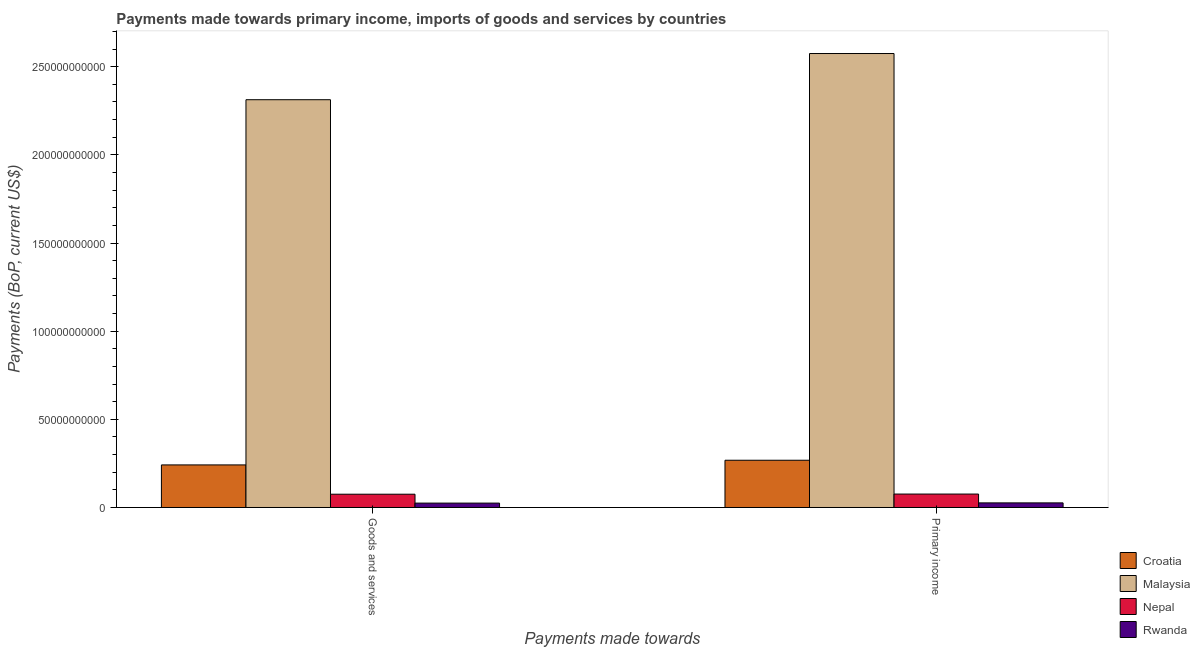How many different coloured bars are there?
Your answer should be very brief. 4. Are the number of bars per tick equal to the number of legend labels?
Your answer should be compact. Yes. How many bars are there on the 1st tick from the left?
Your answer should be compact. 4. How many bars are there on the 2nd tick from the right?
Your response must be concise. 4. What is the label of the 1st group of bars from the left?
Provide a succinct answer. Goods and services. What is the payments made towards primary income in Malaysia?
Ensure brevity in your answer.  2.57e+11. Across all countries, what is the maximum payments made towards goods and services?
Your answer should be compact. 2.31e+11. Across all countries, what is the minimum payments made towards primary income?
Your response must be concise. 2.61e+09. In which country was the payments made towards goods and services maximum?
Provide a short and direct response. Malaysia. In which country was the payments made towards primary income minimum?
Ensure brevity in your answer.  Rwanda. What is the total payments made towards primary income in the graph?
Give a very brief answer. 2.95e+11. What is the difference between the payments made towards goods and services in Rwanda and that in Malaysia?
Provide a short and direct response. -2.29e+11. What is the difference between the payments made towards goods and services in Croatia and the payments made towards primary income in Malaysia?
Ensure brevity in your answer.  -2.33e+11. What is the average payments made towards primary income per country?
Your response must be concise. 7.36e+1. What is the difference between the payments made towards primary income and payments made towards goods and services in Malaysia?
Provide a short and direct response. 2.62e+1. What is the ratio of the payments made towards goods and services in Croatia to that in Rwanda?
Keep it short and to the point. 9.72. Is the payments made towards goods and services in Nepal less than that in Malaysia?
Keep it short and to the point. Yes. What does the 2nd bar from the left in Primary income represents?
Give a very brief answer. Malaysia. What does the 2nd bar from the right in Primary income represents?
Provide a short and direct response. Nepal. How many bars are there?
Ensure brevity in your answer.  8. Are all the bars in the graph horizontal?
Give a very brief answer. No. Are the values on the major ticks of Y-axis written in scientific E-notation?
Ensure brevity in your answer.  No. How many legend labels are there?
Offer a terse response. 4. How are the legend labels stacked?
Offer a terse response. Vertical. What is the title of the graph?
Your answer should be very brief. Payments made towards primary income, imports of goods and services by countries. What is the label or title of the X-axis?
Offer a terse response. Payments made towards. What is the label or title of the Y-axis?
Provide a short and direct response. Payments (BoP, current US$). What is the Payments (BoP, current US$) in Croatia in Goods and services?
Keep it short and to the point. 2.42e+1. What is the Payments (BoP, current US$) of Malaysia in Goods and services?
Your response must be concise. 2.31e+11. What is the Payments (BoP, current US$) in Nepal in Goods and services?
Provide a succinct answer. 7.53e+09. What is the Payments (BoP, current US$) in Rwanda in Goods and services?
Give a very brief answer. 2.48e+09. What is the Payments (BoP, current US$) of Croatia in Primary income?
Your response must be concise. 2.68e+1. What is the Payments (BoP, current US$) in Malaysia in Primary income?
Give a very brief answer. 2.57e+11. What is the Payments (BoP, current US$) of Nepal in Primary income?
Your answer should be compact. 7.62e+09. What is the Payments (BoP, current US$) of Rwanda in Primary income?
Give a very brief answer. 2.61e+09. Across all Payments made towards, what is the maximum Payments (BoP, current US$) in Croatia?
Keep it short and to the point. 2.68e+1. Across all Payments made towards, what is the maximum Payments (BoP, current US$) in Malaysia?
Make the answer very short. 2.57e+11. Across all Payments made towards, what is the maximum Payments (BoP, current US$) of Nepal?
Provide a short and direct response. 7.62e+09. Across all Payments made towards, what is the maximum Payments (BoP, current US$) in Rwanda?
Make the answer very short. 2.61e+09. Across all Payments made towards, what is the minimum Payments (BoP, current US$) in Croatia?
Offer a terse response. 2.42e+1. Across all Payments made towards, what is the minimum Payments (BoP, current US$) of Malaysia?
Keep it short and to the point. 2.31e+11. Across all Payments made towards, what is the minimum Payments (BoP, current US$) of Nepal?
Give a very brief answer. 7.53e+09. Across all Payments made towards, what is the minimum Payments (BoP, current US$) in Rwanda?
Make the answer very short. 2.48e+09. What is the total Payments (BoP, current US$) in Croatia in the graph?
Your answer should be very brief. 5.09e+1. What is the total Payments (BoP, current US$) of Malaysia in the graph?
Offer a very short reply. 4.89e+11. What is the total Payments (BoP, current US$) of Nepal in the graph?
Your answer should be very brief. 1.51e+1. What is the total Payments (BoP, current US$) of Rwanda in the graph?
Provide a succinct answer. 5.10e+09. What is the difference between the Payments (BoP, current US$) in Croatia in Goods and services and that in Primary income?
Your answer should be very brief. -2.64e+09. What is the difference between the Payments (BoP, current US$) of Malaysia in Goods and services and that in Primary income?
Your answer should be very brief. -2.62e+1. What is the difference between the Payments (BoP, current US$) in Nepal in Goods and services and that in Primary income?
Your answer should be very brief. -9.06e+07. What is the difference between the Payments (BoP, current US$) in Rwanda in Goods and services and that in Primary income?
Ensure brevity in your answer.  -1.30e+08. What is the difference between the Payments (BoP, current US$) of Croatia in Goods and services and the Payments (BoP, current US$) of Malaysia in Primary income?
Your answer should be very brief. -2.33e+11. What is the difference between the Payments (BoP, current US$) of Croatia in Goods and services and the Payments (BoP, current US$) of Nepal in Primary income?
Your response must be concise. 1.65e+1. What is the difference between the Payments (BoP, current US$) in Croatia in Goods and services and the Payments (BoP, current US$) in Rwanda in Primary income?
Keep it short and to the point. 2.15e+1. What is the difference between the Payments (BoP, current US$) in Malaysia in Goods and services and the Payments (BoP, current US$) in Nepal in Primary income?
Provide a succinct answer. 2.24e+11. What is the difference between the Payments (BoP, current US$) in Malaysia in Goods and services and the Payments (BoP, current US$) in Rwanda in Primary income?
Keep it short and to the point. 2.29e+11. What is the difference between the Payments (BoP, current US$) in Nepal in Goods and services and the Payments (BoP, current US$) in Rwanda in Primary income?
Your response must be concise. 4.91e+09. What is the average Payments (BoP, current US$) in Croatia per Payments made towards?
Your response must be concise. 2.55e+1. What is the average Payments (BoP, current US$) of Malaysia per Payments made towards?
Give a very brief answer. 2.44e+11. What is the average Payments (BoP, current US$) of Nepal per Payments made towards?
Give a very brief answer. 7.57e+09. What is the average Payments (BoP, current US$) in Rwanda per Payments made towards?
Provide a short and direct response. 2.55e+09. What is the difference between the Payments (BoP, current US$) of Croatia and Payments (BoP, current US$) of Malaysia in Goods and services?
Keep it short and to the point. -2.07e+11. What is the difference between the Payments (BoP, current US$) of Croatia and Payments (BoP, current US$) of Nepal in Goods and services?
Provide a succinct answer. 1.66e+1. What is the difference between the Payments (BoP, current US$) in Croatia and Payments (BoP, current US$) in Rwanda in Goods and services?
Your answer should be compact. 2.17e+1. What is the difference between the Payments (BoP, current US$) of Malaysia and Payments (BoP, current US$) of Nepal in Goods and services?
Your answer should be compact. 2.24e+11. What is the difference between the Payments (BoP, current US$) in Malaysia and Payments (BoP, current US$) in Rwanda in Goods and services?
Your answer should be very brief. 2.29e+11. What is the difference between the Payments (BoP, current US$) in Nepal and Payments (BoP, current US$) in Rwanda in Goods and services?
Your answer should be very brief. 5.04e+09. What is the difference between the Payments (BoP, current US$) in Croatia and Payments (BoP, current US$) in Malaysia in Primary income?
Provide a short and direct response. -2.31e+11. What is the difference between the Payments (BoP, current US$) of Croatia and Payments (BoP, current US$) of Nepal in Primary income?
Offer a terse response. 1.92e+1. What is the difference between the Payments (BoP, current US$) of Croatia and Payments (BoP, current US$) of Rwanda in Primary income?
Your answer should be compact. 2.42e+1. What is the difference between the Payments (BoP, current US$) in Malaysia and Payments (BoP, current US$) in Nepal in Primary income?
Your answer should be very brief. 2.50e+11. What is the difference between the Payments (BoP, current US$) in Malaysia and Payments (BoP, current US$) in Rwanda in Primary income?
Your answer should be compact. 2.55e+11. What is the difference between the Payments (BoP, current US$) in Nepal and Payments (BoP, current US$) in Rwanda in Primary income?
Make the answer very short. 5.00e+09. What is the ratio of the Payments (BoP, current US$) in Croatia in Goods and services to that in Primary income?
Your answer should be compact. 0.9. What is the ratio of the Payments (BoP, current US$) of Malaysia in Goods and services to that in Primary income?
Offer a terse response. 0.9. What is the ratio of the Payments (BoP, current US$) of Nepal in Goods and services to that in Primary income?
Your answer should be very brief. 0.99. What is the ratio of the Payments (BoP, current US$) of Rwanda in Goods and services to that in Primary income?
Your response must be concise. 0.95. What is the difference between the highest and the second highest Payments (BoP, current US$) in Croatia?
Provide a succinct answer. 2.64e+09. What is the difference between the highest and the second highest Payments (BoP, current US$) in Malaysia?
Make the answer very short. 2.62e+1. What is the difference between the highest and the second highest Payments (BoP, current US$) of Nepal?
Your answer should be very brief. 9.06e+07. What is the difference between the highest and the second highest Payments (BoP, current US$) in Rwanda?
Your answer should be very brief. 1.30e+08. What is the difference between the highest and the lowest Payments (BoP, current US$) in Croatia?
Offer a very short reply. 2.64e+09. What is the difference between the highest and the lowest Payments (BoP, current US$) in Malaysia?
Offer a terse response. 2.62e+1. What is the difference between the highest and the lowest Payments (BoP, current US$) of Nepal?
Give a very brief answer. 9.06e+07. What is the difference between the highest and the lowest Payments (BoP, current US$) of Rwanda?
Give a very brief answer. 1.30e+08. 